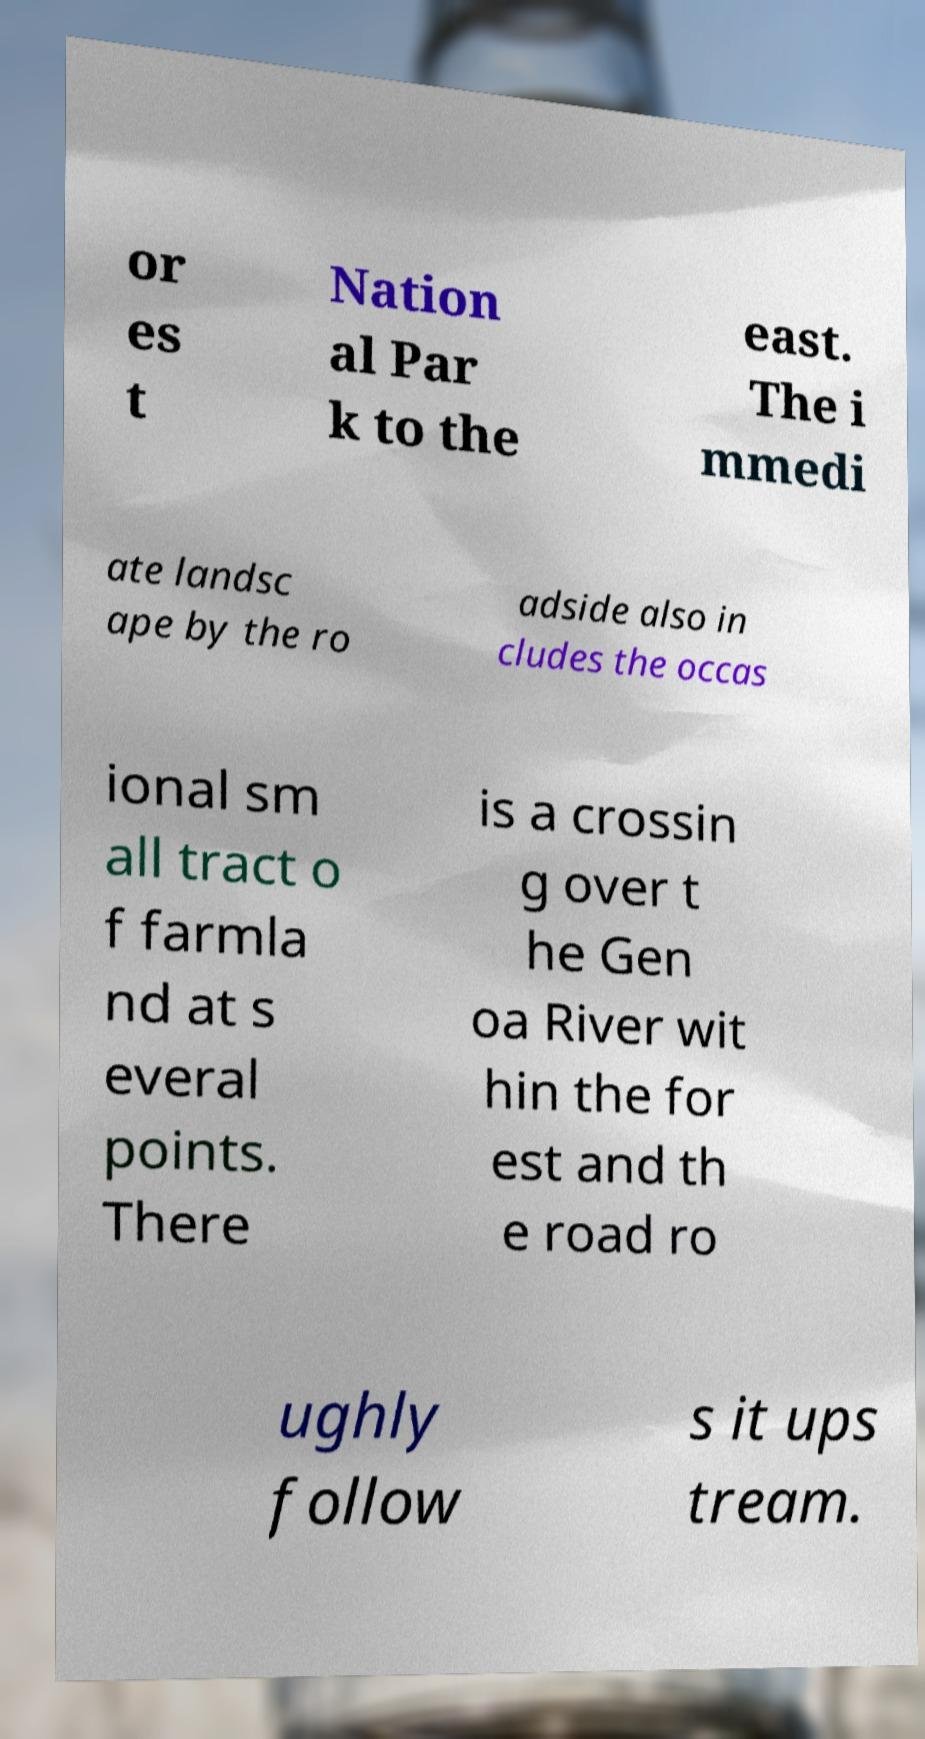I need the written content from this picture converted into text. Can you do that? or es t Nation al Par k to the east. The i mmedi ate landsc ape by the ro adside also in cludes the occas ional sm all tract o f farmla nd at s everal points. There is a crossin g over t he Gen oa River wit hin the for est and th e road ro ughly follow s it ups tream. 